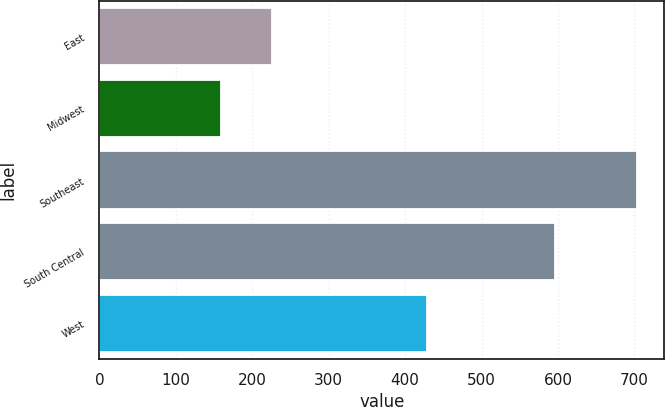Convert chart. <chart><loc_0><loc_0><loc_500><loc_500><bar_chart><fcel>East<fcel>Midwest<fcel>Southeast<fcel>South Central<fcel>West<nl><fcel>226.3<fcel>159.4<fcel>703.7<fcel>595.8<fcel>428.8<nl></chart> 